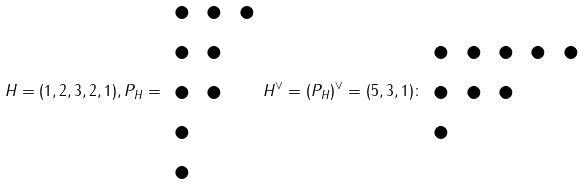Convert formula to latex. <formula><loc_0><loc_0><loc_500><loc_500>H = ( 1 , 2 , 3 , 2 , 1 ) , P _ { H } = \begin{array} { c c c } \bullet & \bullet & \bullet \\ \bullet & \bullet & \\ \bullet & \bullet & \\ \bullet & & \\ \bullet & & \end{array} H ^ { \vee } = ( P _ { H } ) ^ { \vee } = ( 5 , 3 , 1 ) \colon \begin{array} { c c c c c } \bullet & \bullet & \bullet & \bullet & \bullet \\ \bullet & \bullet & \bullet & & \\ \bullet & & & & \end{array}</formula> 